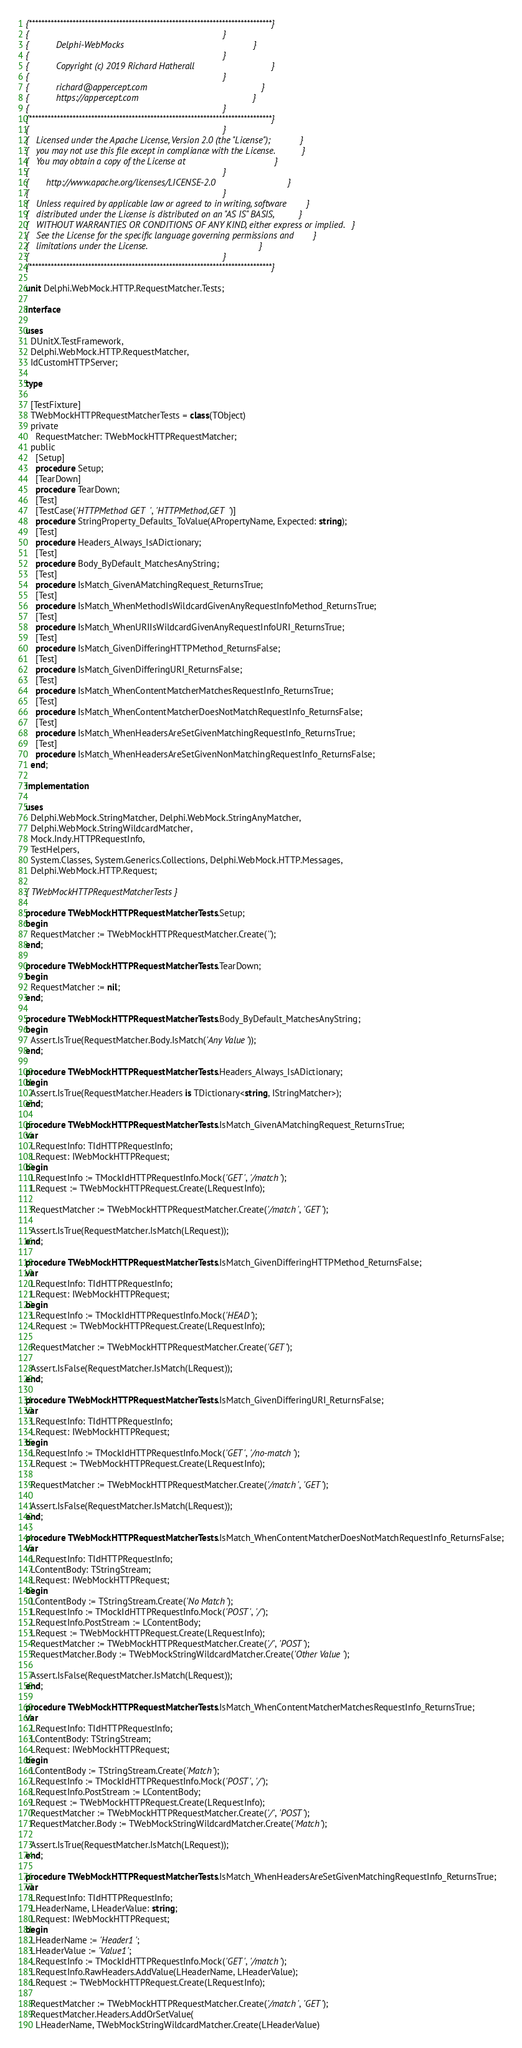Convert code to text. <code><loc_0><loc_0><loc_500><loc_500><_Pascal_>{******************************************************************************}
{                                                                              }
{           Delphi-WebMocks                                                    }
{                                                                              }
{           Copyright (c) 2019 Richard Hatherall                               }
{                                                                              }
{           richard@appercept.com                                              }
{           https://appercept.com                                              }
{                                                                              }
{******************************************************************************}
{                                                                              }
{   Licensed under the Apache License, Version 2.0 (the "License");            }
{   you may not use this file except in compliance with the License.           }
{   You may obtain a copy of the License at                                    }
{                                                                              }
{       http://www.apache.org/licenses/LICENSE-2.0                             }
{                                                                              }
{   Unless required by applicable law or agreed to in writing, software        }
{   distributed under the License is distributed on an "AS IS" BASIS,          }
{   WITHOUT WARRANTIES OR CONDITIONS OF ANY KIND, either express or implied.   }
{   See the License for the specific language governing permissions and        }
{   limitations under the License.                                             }
{                                                                              }
{******************************************************************************}

unit Delphi.WebMock.HTTP.RequestMatcher.Tests;

interface

uses
  DUnitX.TestFramework,
  Delphi.WebMock.HTTP.RequestMatcher,
  IdCustomHTTPServer;

type

  [TestFixture]
  TWebMockHTTPRequestMatcherTests = class(TObject)
  private
    RequestMatcher: TWebMockHTTPRequestMatcher;
  public
    [Setup]
    procedure Setup;
    [TearDown]
    procedure TearDown;
    [Test]
    [TestCase('HTTPMethod GET', 'HTTPMethod,GET')]
    procedure StringProperty_Defaults_ToValue(APropertyName, Expected: string);
    [Test]
    procedure Headers_Always_IsADictionary;
    [Test]
    procedure Body_ByDefault_MatchesAnyString;
    [Test]
    procedure IsMatch_GivenAMatchingRequest_ReturnsTrue;
    [Test]
    procedure IsMatch_WhenMethodIsWildcardGivenAnyRequestInfoMethod_ReturnsTrue;
    [Test]
    procedure IsMatch_WhenURIIsWildcardGivenAnyRequestInfoURI_ReturnsTrue;
    [Test]
    procedure IsMatch_GivenDifferingHTTPMethod_ReturnsFalse;
    [Test]
    procedure IsMatch_GivenDifferingURI_ReturnsFalse;
    [Test]
    procedure IsMatch_WhenContentMatcherMatchesRequestInfo_ReturnsTrue;
    [Test]
    procedure IsMatch_WhenContentMatcherDoesNotMatchRequestInfo_ReturnsFalse;
    [Test]
    procedure IsMatch_WhenHeadersAreSetGivenMatchingRequestInfo_ReturnsTrue;
    [Test]
    procedure IsMatch_WhenHeadersAreSetGivenNonMatchingRequestInfo_ReturnsFalse;
  end;

implementation

uses
  Delphi.WebMock.StringMatcher, Delphi.WebMock.StringAnyMatcher,
  Delphi.WebMock.StringWildcardMatcher,
  Mock.Indy.HTTPRequestInfo,
  TestHelpers,
  System.Classes, System.Generics.Collections, Delphi.WebMock.HTTP.Messages,
  Delphi.WebMock.HTTP.Request;

{ TWebMockHTTPRequestMatcherTests }

procedure TWebMockHTTPRequestMatcherTests.Setup;
begin
  RequestMatcher := TWebMockHTTPRequestMatcher.Create('');
end;

procedure TWebMockHTTPRequestMatcherTests.TearDown;
begin
  RequestMatcher := nil;
end;

procedure TWebMockHTTPRequestMatcherTests.Body_ByDefault_MatchesAnyString;
begin
  Assert.IsTrue(RequestMatcher.Body.IsMatch('Any Value'));
end;

procedure TWebMockHTTPRequestMatcherTests.Headers_Always_IsADictionary;
begin
  Assert.IsTrue(RequestMatcher.Headers is TDictionary<string, IStringMatcher>);
end;

procedure TWebMockHTTPRequestMatcherTests.IsMatch_GivenAMatchingRequest_ReturnsTrue;
var
  LRequestInfo: TIdHTTPRequestInfo;
  LRequest: IWebMockHTTPRequest;
begin
  LRequestInfo := TMockIdHTTPRequestInfo.Mock('GET', '/match');
  LRequest := TWebMockHTTPRequest.Create(LRequestInfo);

  RequestMatcher := TWebMockHTTPRequestMatcher.Create('/match', 'GET');

  Assert.IsTrue(RequestMatcher.IsMatch(LRequest));
end;

procedure TWebMockHTTPRequestMatcherTests.IsMatch_GivenDifferingHTTPMethod_ReturnsFalse;
var
  LRequestInfo: TIdHTTPRequestInfo;
  LRequest: IWebMockHTTPRequest;
begin
  LRequestInfo := TMockIdHTTPRequestInfo.Mock('HEAD');
  LRequest := TWebMockHTTPRequest.Create(LRequestInfo);

  RequestMatcher := TWebMockHTTPRequestMatcher.Create('GET');

  Assert.IsFalse(RequestMatcher.IsMatch(LRequest));
end;

procedure TWebMockHTTPRequestMatcherTests.IsMatch_GivenDifferingURI_ReturnsFalse;
var
  LRequestInfo: TIdHTTPRequestInfo;
  LRequest: IWebMockHTTPRequest;
begin
  LRequestInfo := TMockIdHTTPRequestInfo.Mock('GET', '/no-match');
  LRequest := TWebMockHTTPRequest.Create(LRequestInfo);

  RequestMatcher := TWebMockHTTPRequestMatcher.Create('/match', 'GET');

  Assert.IsFalse(RequestMatcher.IsMatch(LRequest));
end;

procedure TWebMockHTTPRequestMatcherTests.IsMatch_WhenContentMatcherDoesNotMatchRequestInfo_ReturnsFalse;
var
  LRequestInfo: TIdHTTPRequestInfo;
  LContentBody: TStringStream;
  LRequest: IWebMockHTTPRequest;
begin
  LContentBody := TStringStream.Create('No Match');
  LRequestInfo := TMockIdHTTPRequestInfo.Mock('POST', '/');
  LRequestInfo.PostStream := LContentBody;
  LRequest := TWebMockHTTPRequest.Create(LRequestInfo);
  RequestMatcher := TWebMockHTTPRequestMatcher.Create('/', 'POST');
  RequestMatcher.Body := TWebMockStringWildcardMatcher.Create('Other Value');

  Assert.IsFalse(RequestMatcher.IsMatch(LRequest));
end;

procedure TWebMockHTTPRequestMatcherTests.IsMatch_WhenContentMatcherMatchesRequestInfo_ReturnsTrue;
var
  LRequestInfo: TIdHTTPRequestInfo;
  LContentBody: TStringStream;
  LRequest: IWebMockHTTPRequest;
begin
  LContentBody := TStringStream.Create('Match');
  LRequestInfo := TMockIdHTTPRequestInfo.Mock('POST', '/');
  LRequestInfo.PostStream := LContentBody;
  LRequest := TWebMockHTTPRequest.Create(LRequestInfo);
  RequestMatcher := TWebMockHTTPRequestMatcher.Create('/', 'POST');
  RequestMatcher.Body := TWebMockStringWildcardMatcher.Create('Match');

  Assert.IsTrue(RequestMatcher.IsMatch(LRequest));
end;

procedure TWebMockHTTPRequestMatcherTests.IsMatch_WhenHeadersAreSetGivenMatchingRequestInfo_ReturnsTrue;
var
  LRequestInfo: TIdHTTPRequestInfo;
  LHeaderName, LHeaderValue: string;
  LRequest: IWebMockHTTPRequest;
begin
  LHeaderName := 'Header1';
  LHeaderValue := 'Value1';
  LRequestInfo := TMockIdHTTPRequestInfo.Mock('GET', '/match');
  LRequestInfo.RawHeaders.AddValue(LHeaderName, LHeaderValue);
  LRequest := TWebMockHTTPRequest.Create(LRequestInfo);

  RequestMatcher := TWebMockHTTPRequestMatcher.Create('/match', 'GET');
  RequestMatcher.Headers.AddOrSetValue(
    LHeaderName, TWebMockStringWildcardMatcher.Create(LHeaderValue)</code> 